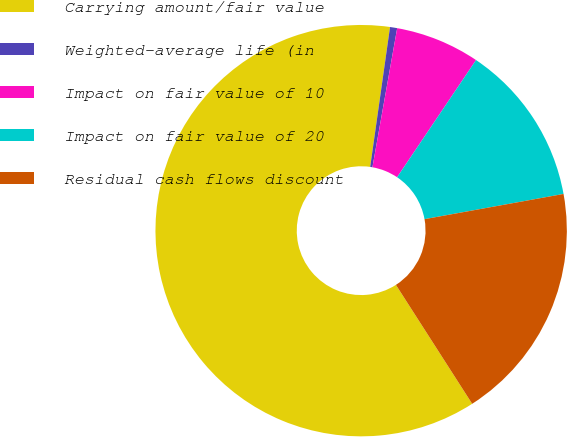Convert chart to OTSL. <chart><loc_0><loc_0><loc_500><loc_500><pie_chart><fcel>Carrying amount/fair value<fcel>Weighted-average life (in<fcel>Impact on fair value of 10<fcel>Impact on fair value of 20<fcel>Residual cash flows discount<nl><fcel>61.31%<fcel>0.56%<fcel>6.63%<fcel>12.71%<fcel>18.78%<nl></chart> 